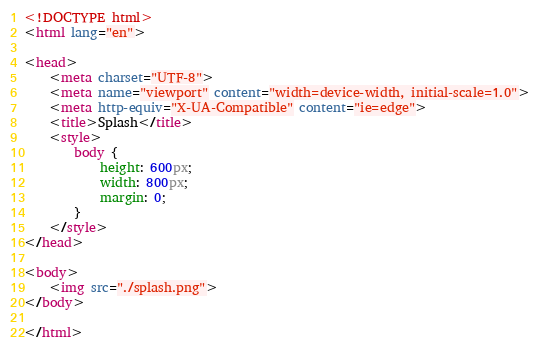Convert code to text. <code><loc_0><loc_0><loc_500><loc_500><_HTML_><!DOCTYPE html>
<html lang="en">

<head>
    <meta charset="UTF-8">
    <meta name="viewport" content="width=device-width, initial-scale=1.0">
    <meta http-equiv="X-UA-Compatible" content="ie=edge">
    <title>Splash</title>
    <style>
        body {
            height: 600px;
            width: 800px;
            margin: 0;
        }
    </style>
</head>

<body>
    <img src="./splash.png">
</body>

</html></code> 